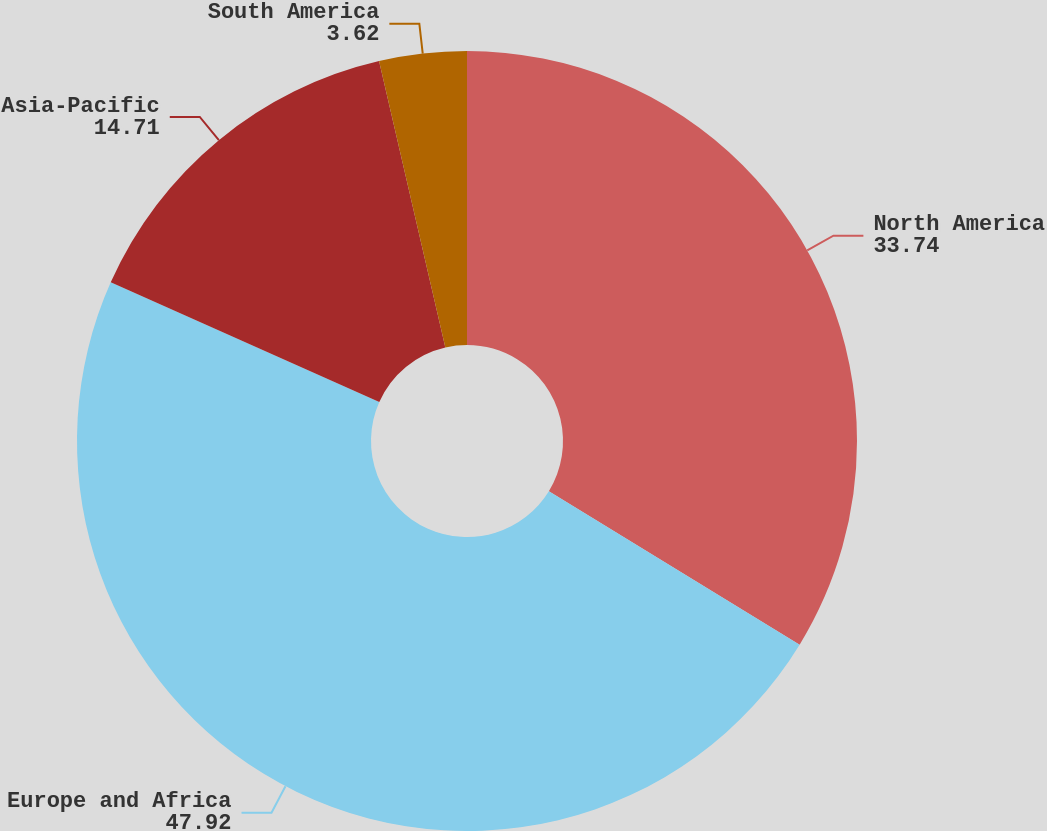Convert chart to OTSL. <chart><loc_0><loc_0><loc_500><loc_500><pie_chart><fcel>North America<fcel>Europe and Africa<fcel>Asia-Pacific<fcel>South America<nl><fcel>33.74%<fcel>47.92%<fcel>14.71%<fcel>3.62%<nl></chart> 